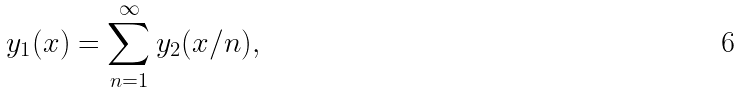<formula> <loc_0><loc_0><loc_500><loc_500>y _ { 1 } ( x ) = \sum _ { n = 1 } ^ { \infty } y _ { 2 } ( x / n ) ,</formula> 